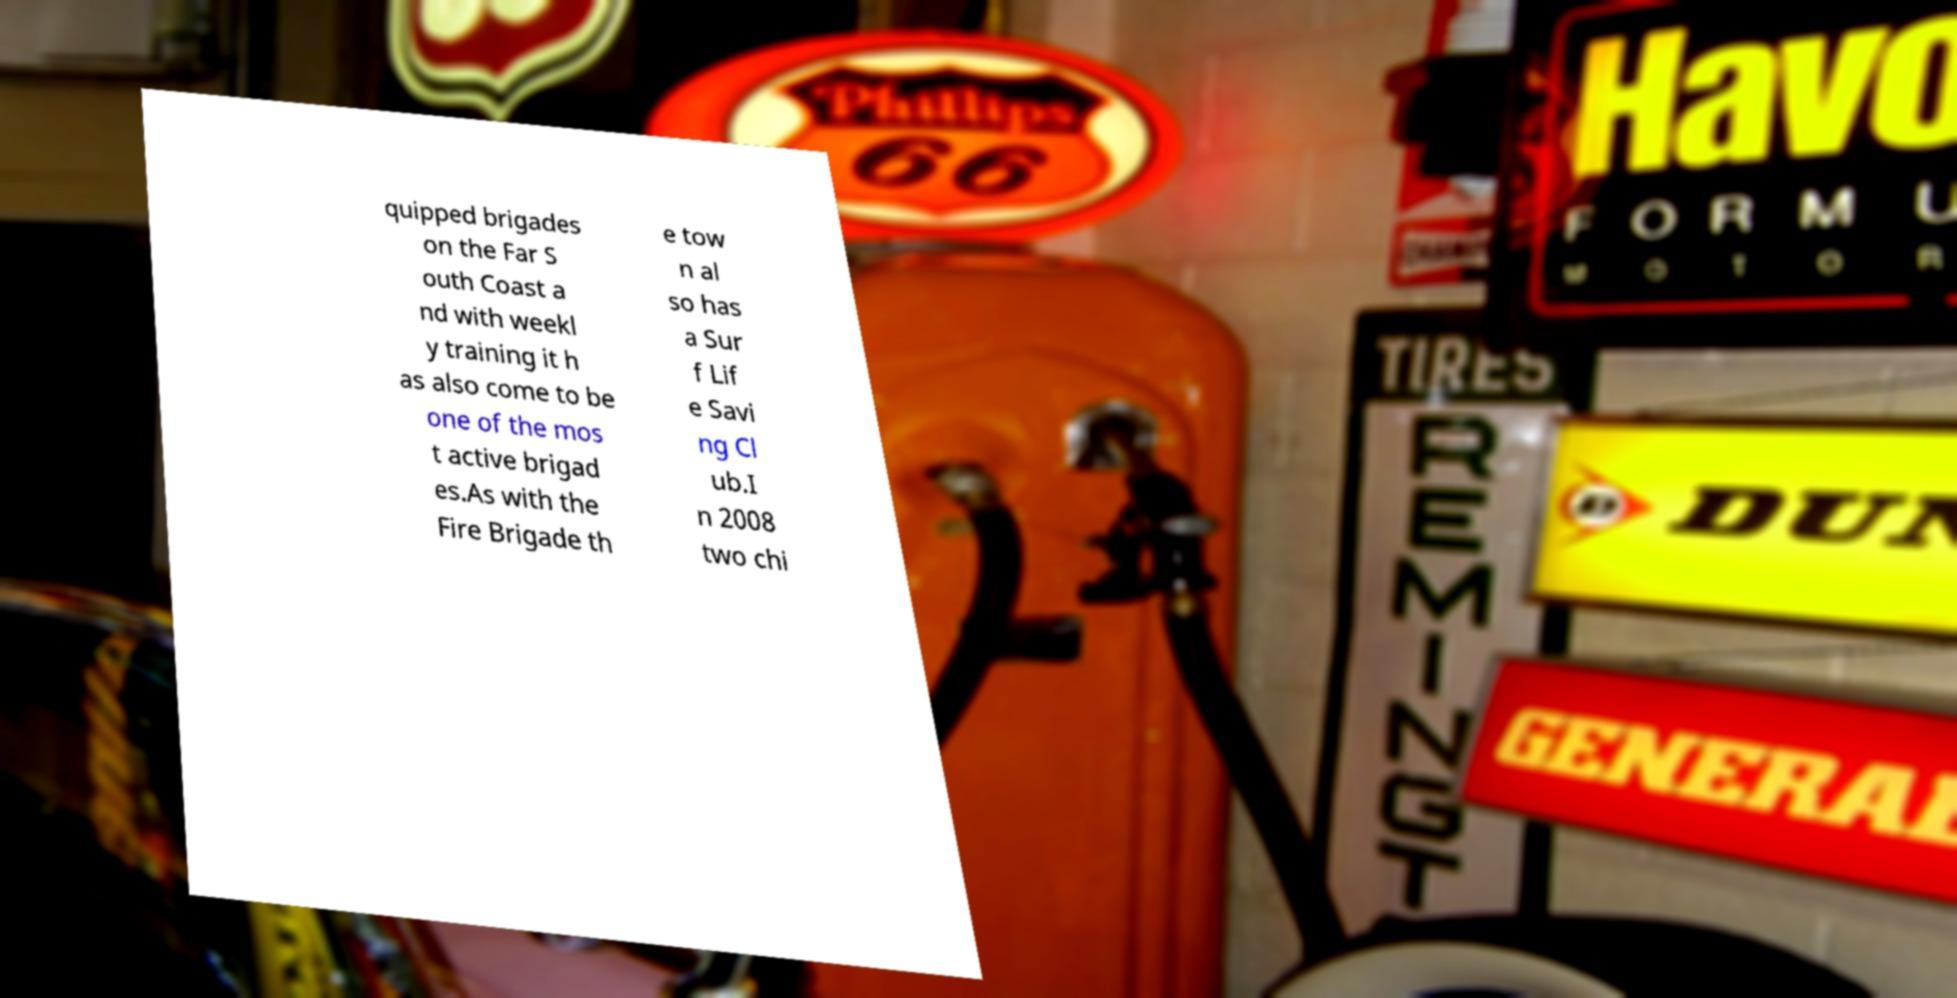For documentation purposes, I need the text within this image transcribed. Could you provide that? quipped brigades on the Far S outh Coast a nd with weekl y training it h as also come to be one of the mos t active brigad es.As with the Fire Brigade th e tow n al so has a Sur f Lif e Savi ng Cl ub.I n 2008 two chi 